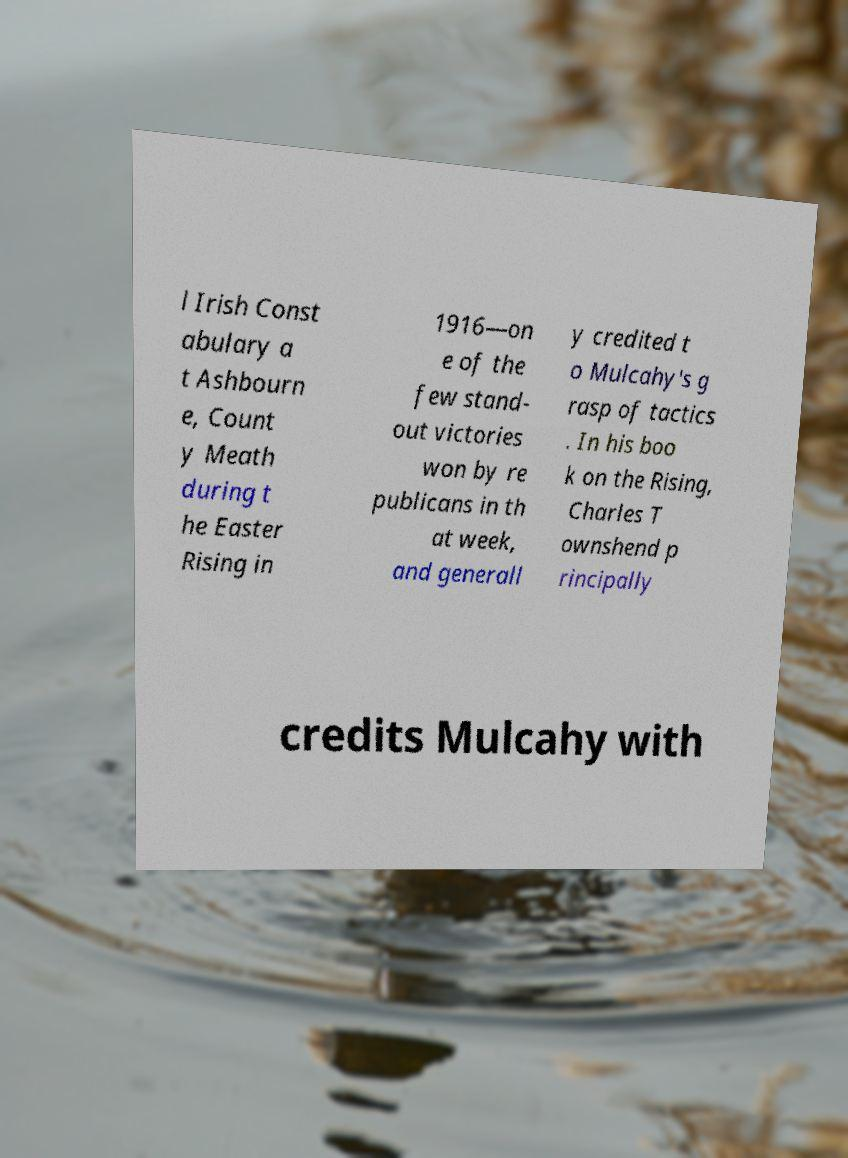Please identify and transcribe the text found in this image. l Irish Const abulary a t Ashbourn e, Count y Meath during t he Easter Rising in 1916—on e of the few stand- out victories won by re publicans in th at week, and generall y credited t o Mulcahy's g rasp of tactics . In his boo k on the Rising, Charles T ownshend p rincipally credits Mulcahy with 